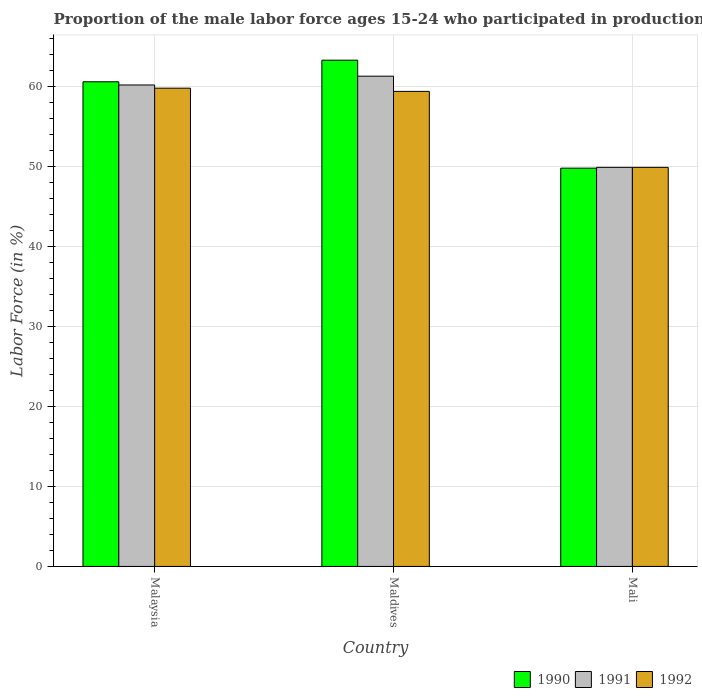Are the number of bars on each tick of the X-axis equal?
Make the answer very short. Yes. How many bars are there on the 2nd tick from the left?
Make the answer very short. 3. What is the label of the 2nd group of bars from the left?
Your response must be concise. Maldives. What is the proportion of the male labor force who participated in production in 1992 in Malaysia?
Offer a terse response. 59.8. Across all countries, what is the maximum proportion of the male labor force who participated in production in 1990?
Make the answer very short. 63.3. Across all countries, what is the minimum proportion of the male labor force who participated in production in 1992?
Offer a terse response. 49.9. In which country was the proportion of the male labor force who participated in production in 1991 maximum?
Ensure brevity in your answer.  Maldives. In which country was the proportion of the male labor force who participated in production in 1990 minimum?
Your response must be concise. Mali. What is the total proportion of the male labor force who participated in production in 1992 in the graph?
Give a very brief answer. 169.1. What is the difference between the proportion of the male labor force who participated in production in 1992 in Malaysia and that in Maldives?
Your answer should be very brief. 0.4. What is the average proportion of the male labor force who participated in production in 1992 per country?
Offer a very short reply. 56.37. What is the difference between the proportion of the male labor force who participated in production of/in 1992 and proportion of the male labor force who participated in production of/in 1991 in Maldives?
Provide a short and direct response. -1.9. What is the ratio of the proportion of the male labor force who participated in production in 1991 in Maldives to that in Mali?
Make the answer very short. 1.23. Is the difference between the proportion of the male labor force who participated in production in 1992 in Malaysia and Maldives greater than the difference between the proportion of the male labor force who participated in production in 1991 in Malaysia and Maldives?
Make the answer very short. Yes. What is the difference between the highest and the second highest proportion of the male labor force who participated in production in 1991?
Keep it short and to the point. -10.3. What is the difference between the highest and the lowest proportion of the male labor force who participated in production in 1991?
Ensure brevity in your answer.  11.4. In how many countries, is the proportion of the male labor force who participated in production in 1990 greater than the average proportion of the male labor force who participated in production in 1990 taken over all countries?
Provide a succinct answer. 2. Is the sum of the proportion of the male labor force who participated in production in 1990 in Malaysia and Maldives greater than the maximum proportion of the male labor force who participated in production in 1991 across all countries?
Make the answer very short. Yes. What does the 3rd bar from the left in Mali represents?
Ensure brevity in your answer.  1992. Is it the case that in every country, the sum of the proportion of the male labor force who participated in production in 1990 and proportion of the male labor force who participated in production in 1992 is greater than the proportion of the male labor force who participated in production in 1991?
Your answer should be compact. Yes. Are all the bars in the graph horizontal?
Offer a terse response. No. Does the graph contain any zero values?
Make the answer very short. No. Does the graph contain grids?
Your answer should be compact. Yes. Where does the legend appear in the graph?
Provide a succinct answer. Bottom right. How many legend labels are there?
Your answer should be very brief. 3. How are the legend labels stacked?
Your answer should be very brief. Horizontal. What is the title of the graph?
Your answer should be very brief. Proportion of the male labor force ages 15-24 who participated in production. What is the label or title of the Y-axis?
Make the answer very short. Labor Force (in %). What is the Labor Force (in %) in 1990 in Malaysia?
Your response must be concise. 60.6. What is the Labor Force (in %) of 1991 in Malaysia?
Your answer should be very brief. 60.2. What is the Labor Force (in %) of 1992 in Malaysia?
Ensure brevity in your answer.  59.8. What is the Labor Force (in %) in 1990 in Maldives?
Give a very brief answer. 63.3. What is the Labor Force (in %) in 1991 in Maldives?
Give a very brief answer. 61.3. What is the Labor Force (in %) of 1992 in Maldives?
Your answer should be very brief. 59.4. What is the Labor Force (in %) of 1990 in Mali?
Give a very brief answer. 49.8. What is the Labor Force (in %) of 1991 in Mali?
Offer a very short reply. 49.9. What is the Labor Force (in %) in 1992 in Mali?
Keep it short and to the point. 49.9. Across all countries, what is the maximum Labor Force (in %) in 1990?
Offer a terse response. 63.3. Across all countries, what is the maximum Labor Force (in %) of 1991?
Provide a succinct answer. 61.3. Across all countries, what is the maximum Labor Force (in %) of 1992?
Keep it short and to the point. 59.8. Across all countries, what is the minimum Labor Force (in %) in 1990?
Offer a terse response. 49.8. Across all countries, what is the minimum Labor Force (in %) of 1991?
Provide a short and direct response. 49.9. Across all countries, what is the minimum Labor Force (in %) in 1992?
Provide a short and direct response. 49.9. What is the total Labor Force (in %) in 1990 in the graph?
Keep it short and to the point. 173.7. What is the total Labor Force (in %) in 1991 in the graph?
Provide a succinct answer. 171.4. What is the total Labor Force (in %) of 1992 in the graph?
Ensure brevity in your answer.  169.1. What is the difference between the Labor Force (in %) in 1992 in Malaysia and that in Maldives?
Provide a short and direct response. 0.4. What is the difference between the Labor Force (in %) in 1990 in Malaysia and that in Mali?
Offer a terse response. 10.8. What is the difference between the Labor Force (in %) in 1991 in Malaysia and that in Mali?
Your answer should be very brief. 10.3. What is the difference between the Labor Force (in %) of 1992 in Malaysia and that in Mali?
Give a very brief answer. 9.9. What is the difference between the Labor Force (in %) in 1990 in Malaysia and the Labor Force (in %) in 1991 in Maldives?
Keep it short and to the point. -0.7. What is the difference between the Labor Force (in %) in 1990 in Malaysia and the Labor Force (in %) in 1992 in Maldives?
Offer a terse response. 1.2. What is the difference between the Labor Force (in %) of 1991 in Malaysia and the Labor Force (in %) of 1992 in Maldives?
Offer a very short reply. 0.8. What is the difference between the Labor Force (in %) in 1990 in Malaysia and the Labor Force (in %) in 1991 in Mali?
Your response must be concise. 10.7. What is the difference between the Labor Force (in %) of 1990 in Malaysia and the Labor Force (in %) of 1992 in Mali?
Your response must be concise. 10.7. What is the difference between the Labor Force (in %) of 1991 in Malaysia and the Labor Force (in %) of 1992 in Mali?
Your response must be concise. 10.3. What is the average Labor Force (in %) in 1990 per country?
Ensure brevity in your answer.  57.9. What is the average Labor Force (in %) in 1991 per country?
Keep it short and to the point. 57.13. What is the average Labor Force (in %) of 1992 per country?
Provide a short and direct response. 56.37. What is the difference between the Labor Force (in %) in 1990 and Labor Force (in %) in 1991 in Malaysia?
Give a very brief answer. 0.4. What is the difference between the Labor Force (in %) in 1990 and Labor Force (in %) in 1992 in Malaysia?
Give a very brief answer. 0.8. What is the difference between the Labor Force (in %) of 1990 and Labor Force (in %) of 1991 in Maldives?
Make the answer very short. 2. What is the difference between the Labor Force (in %) in 1990 and Labor Force (in %) in 1991 in Mali?
Ensure brevity in your answer.  -0.1. What is the difference between the Labor Force (in %) of 1990 and Labor Force (in %) of 1992 in Mali?
Give a very brief answer. -0.1. What is the ratio of the Labor Force (in %) in 1990 in Malaysia to that in Maldives?
Provide a succinct answer. 0.96. What is the ratio of the Labor Force (in %) of 1991 in Malaysia to that in Maldives?
Give a very brief answer. 0.98. What is the ratio of the Labor Force (in %) in 1992 in Malaysia to that in Maldives?
Your response must be concise. 1.01. What is the ratio of the Labor Force (in %) in 1990 in Malaysia to that in Mali?
Give a very brief answer. 1.22. What is the ratio of the Labor Force (in %) of 1991 in Malaysia to that in Mali?
Provide a short and direct response. 1.21. What is the ratio of the Labor Force (in %) in 1992 in Malaysia to that in Mali?
Make the answer very short. 1.2. What is the ratio of the Labor Force (in %) in 1990 in Maldives to that in Mali?
Provide a short and direct response. 1.27. What is the ratio of the Labor Force (in %) of 1991 in Maldives to that in Mali?
Ensure brevity in your answer.  1.23. What is the ratio of the Labor Force (in %) of 1992 in Maldives to that in Mali?
Provide a short and direct response. 1.19. What is the difference between the highest and the lowest Labor Force (in %) in 1990?
Ensure brevity in your answer.  13.5. What is the difference between the highest and the lowest Labor Force (in %) in 1991?
Your answer should be compact. 11.4. What is the difference between the highest and the lowest Labor Force (in %) in 1992?
Keep it short and to the point. 9.9. 